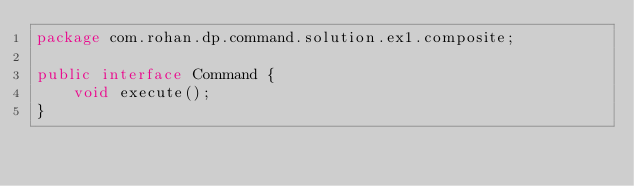Convert code to text. <code><loc_0><loc_0><loc_500><loc_500><_Java_>package com.rohan.dp.command.solution.ex1.composite;

public interface Command {
    void execute();
}
</code> 